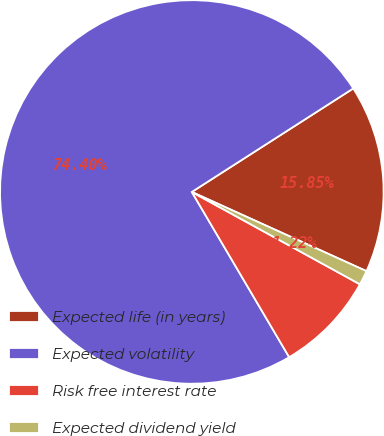Convert chart. <chart><loc_0><loc_0><loc_500><loc_500><pie_chart><fcel>Expected life (in years)<fcel>Expected volatility<fcel>Risk free interest rate<fcel>Expected dividend yield<nl><fcel>15.85%<fcel>74.4%<fcel>8.53%<fcel>1.22%<nl></chart> 